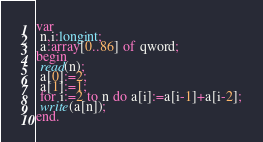<code> <loc_0><loc_0><loc_500><loc_500><_Pascal_>var
 n,i:longint;
 a:array[0..86] of qword;
begin
 read(n);
 a[0]:=2;
 a[1]:=1;
 for i:=2 to n do a[i]:=a[i-1]+a[i-2];
 write(a[n]);
end.</code> 